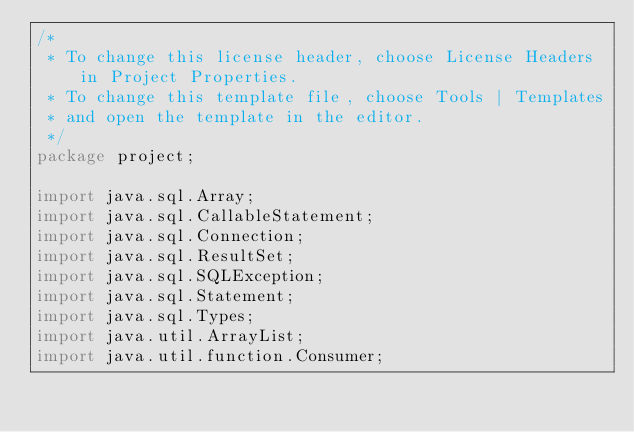Convert code to text. <code><loc_0><loc_0><loc_500><loc_500><_Java_>/*
 * To change this license header, choose License Headers in Project Properties.
 * To change this template file, choose Tools | Templates
 * and open the template in the editor.
 */
package project;

import java.sql.Array;
import java.sql.CallableStatement;
import java.sql.Connection;
import java.sql.ResultSet;
import java.sql.SQLException;
import java.sql.Statement;
import java.sql.Types;
import java.util.ArrayList;
import java.util.function.Consumer;</code> 